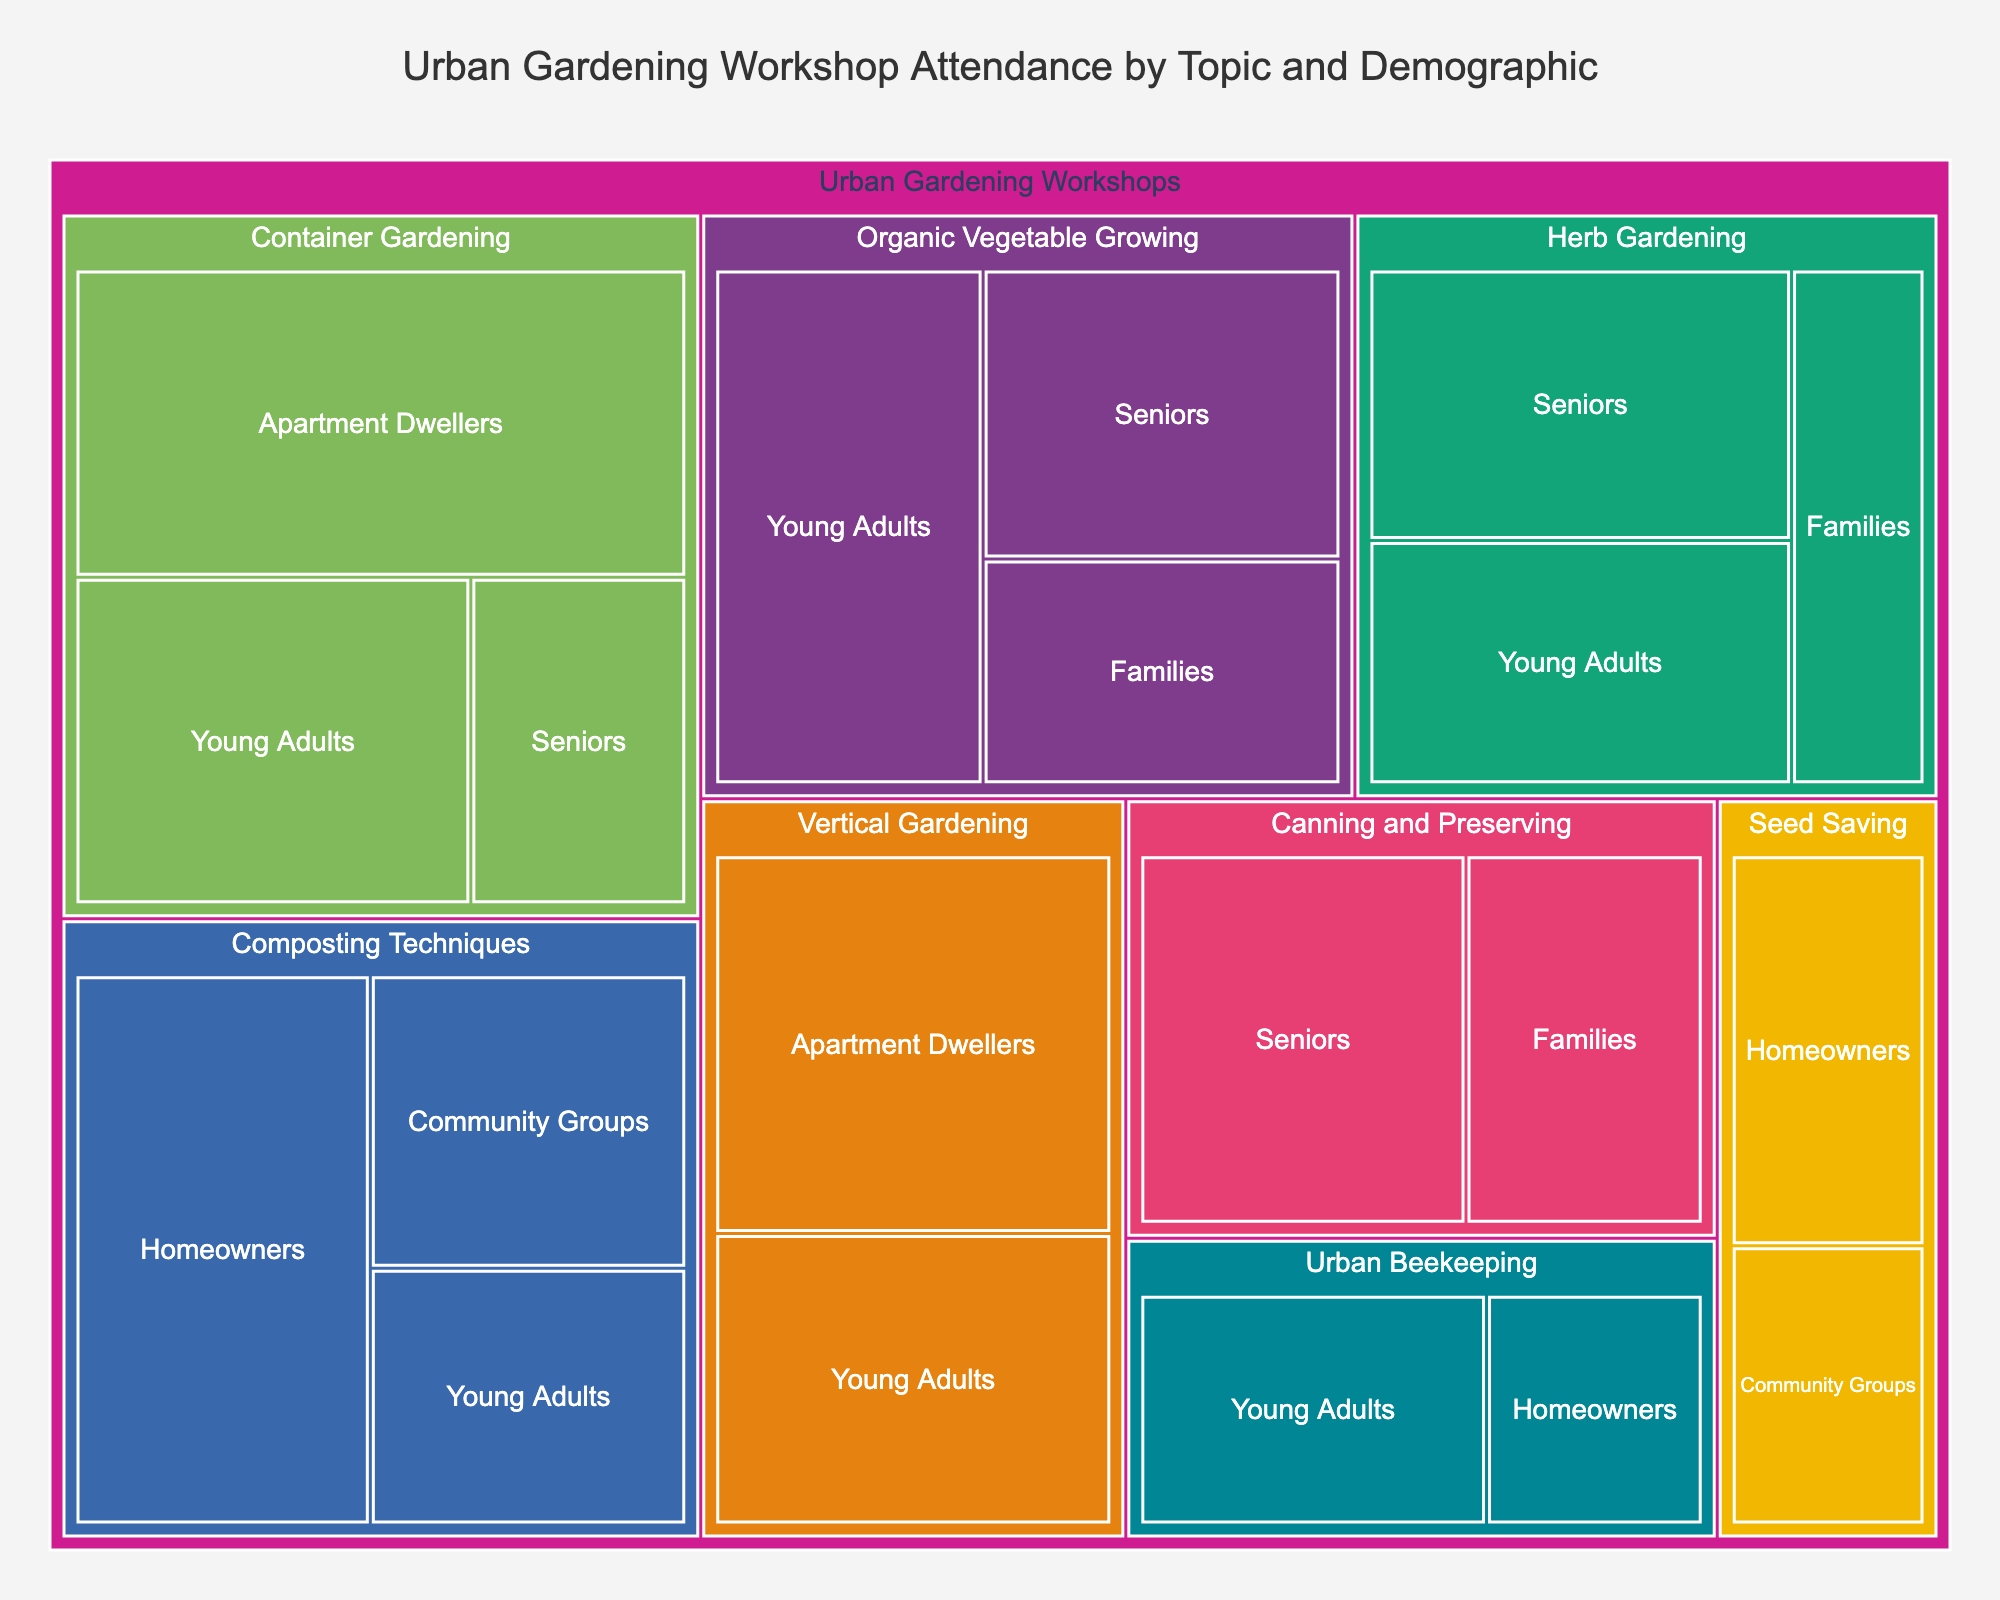What is the title of the treemap? The title is usually displayed at the top of the treemap. It provides an overview of what the treemap represents. By looking at the top, one can find the title.
Answer: Urban Gardening Workshop Attendance by Topic and Demographic Which urban gardening topic has the highest attendance? The sizes of the blocks in the treemap represent the number of attendees. The largest block corresponds to the topic with the highest attendance.
Answer: Container Gardening How many seniors attended Organic Vegetable Growing workshops? Navigate to the section of the treemap labeled "Organic Vegetable Growing" and look for the block labeled "Seniors." The value represented by the block will give the answer.
Answer: 45 Which demographic group attended Vertical Gardening workshops the most? From the section of the treemap labeled "Vertical Gardening," compare the sizes of the blocks for each demographic group to determine which is the largest.
Answer: Apartment Dwellers How many attendees were there in total for the Container Gardening workshops? Add the number of attendees for each demographic within the "Container Gardening" section. The values are 80 (Apartment Dwellers), 30 (Seniors), and 55 (Young Adults). So, 80 + 30 + 55 = 165.
Answer: 165 Which topic has the least participation from Community Groups? Locate the "Community Groups" demographic across different topics in the treemap and compare their block sizes. The smallest block indicates the least participation.
Answer: Seed Saving What is the difference in attendance between Herb Gardening and Urban Beekeeping workshops for Young Adults? Find the "Young Adults" blocks under both "Herb Gardening" and "Urban Beekeeping." The attendance for Herb Gardening is 45 and for Urban Beekeeping is 40. Calculate the difference: 45 - 40 = 5.
Answer: 5 Compare the participation of Seniors in Organic Vegetable Growing to their participation in Canning and Preserving. Which has more attendees? Check the "Seniors" blocks under both "Organic Vegetable Growing" and "Canning and Preserving." Organic Vegetable Growing has 45 attendees, while Canning and Preserving has 55. Thus, Canning and Preserving has more attendees.
Answer: Canning and Preserving How many total attendees are there for all Young Adults across all workshops? Sum the number of attendees for "Young Adults" across all topics. These values are 60 (Organic Vegetable Growing), 55 (Container Gardening), 35 (Composting Techniques), 40 (Urban Beekeeping), 45 (Herb Gardening), and 50 (Vertical Gardening). So, 60 + 55 + 35 + 40 + 45 + 50 = 285.
Answer: 285 